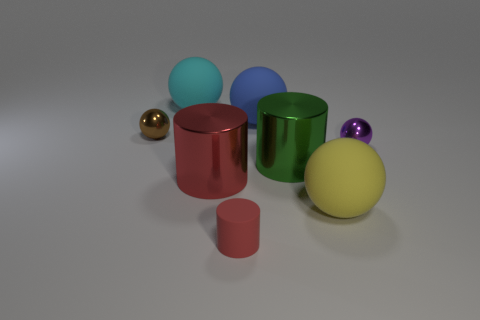Are there the same number of small purple spheres that are in front of the large yellow sphere and big yellow spheres in front of the purple metal ball? Upon examining the image closely, it appears that the small purple spheres in front of the large yellow sphere do not match in number with any big yellow spheres in front of the purple metal cylinder. If we consider spatial placement and relative sizes, we can observe that there is only one small purple sphere and no large yellow spheres positioned directly in front of the purple cylinder. Thus, the answer is no; they do not have the same count. 